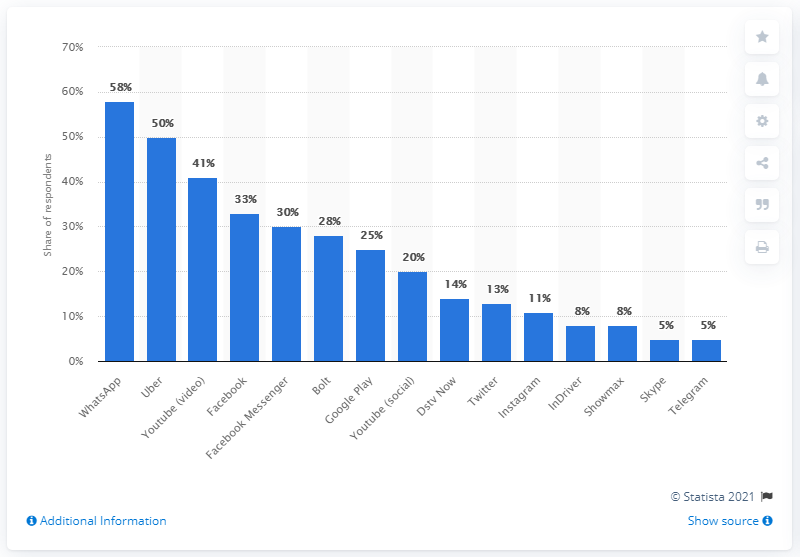Point out several critical features in this image. Uber is the second most popular taxi app in South Africa. 